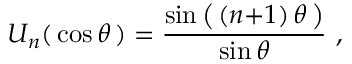<formula> <loc_0><loc_0><loc_500><loc_500>U _ { n } ( \, \cos \theta \, ) = { \frac { \sin { \left ( } \, ( n { + } 1 ) \, \theta \, { \right ) } } { \sin \theta } } ,</formula> 